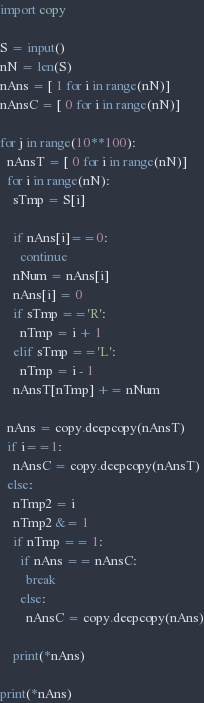<code> <loc_0><loc_0><loc_500><loc_500><_Python_>import copy

S = input()
nN = len(S)
nAns = [ 1 for i in range(nN)]
nAnsC = [ 0 for i in range(nN)]

for j in range(10**100):
  nAnsT = [ 0 for i in range(nN)]
  for i in range(nN):
    sTmp = S[i]
    
    if nAns[i]==0:
      continue
    nNum = nAns[i]
    nAns[i] = 0
    if sTmp =='R':
      nTmp = i + 1
    elif sTmp =='L':
      nTmp = i - 1
    nAnsT[nTmp] += nNum
  
  nAns = copy.deepcopy(nAnsT)
  if i==1:
    nAnsC = copy.deepcopy(nAnsT)
  else:
    nTmp2 = i
    nTmp2 &= 1
    if nTmp == 1:
      if nAns == nAnsC:
        break
      else:
        nAnsC = copy.deepcopy(nAns)
      
    print(*nAns)
  
print(*nAns)

</code> 